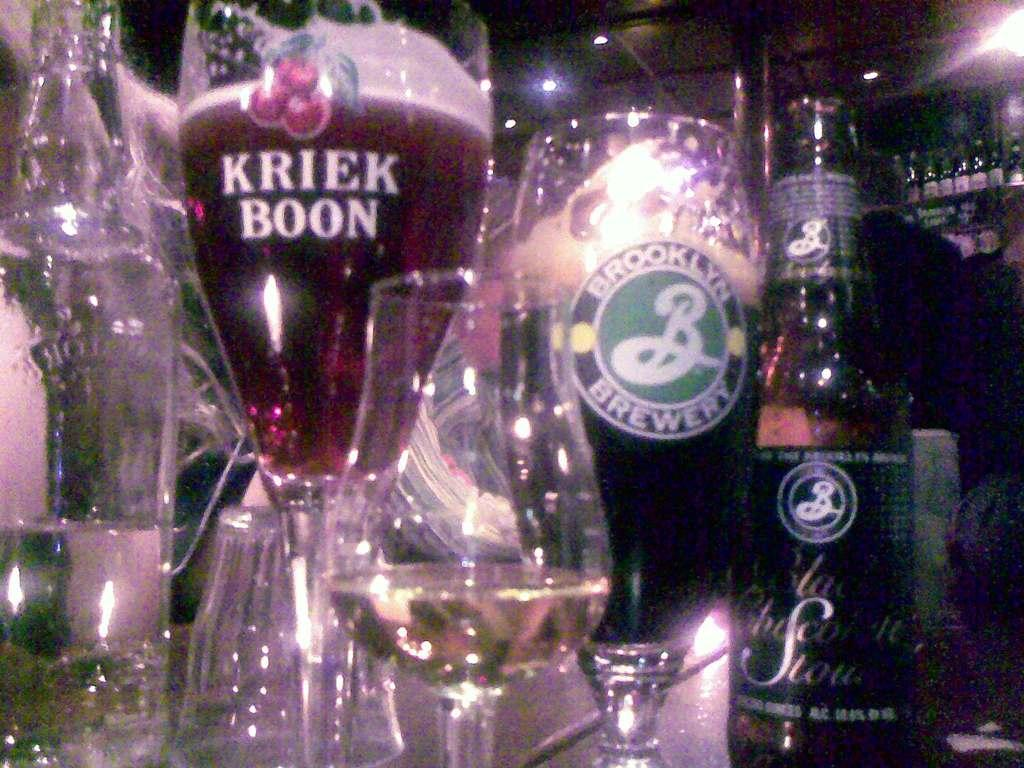What type of glasses are on the table in the image? There are wine glasses on the table in the image. What else is on the table besides the wine glasses? There are wine bottles on the table in the image. Can you describe the person in the image? There is a person standing at the back of the image. What is visible at the top of the image? There are lights visible at the top of the image. Where is the toothbrush located in the image? There is no toothbrush present in the image. What type of cave can be seen in the background of the image? There is no cave present in the image; it features a table with wine glasses and bottles, lights, and a person standing at the back. 